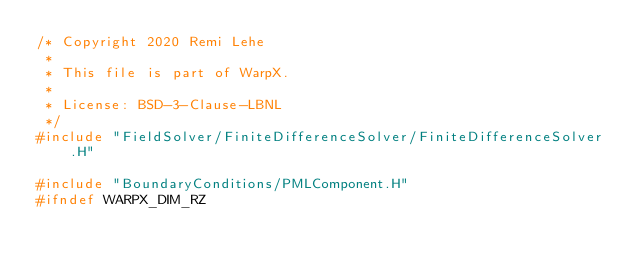Convert code to text. <code><loc_0><loc_0><loc_500><loc_500><_C++_>/* Copyright 2020 Remi Lehe
 *
 * This file is part of WarpX.
 *
 * License: BSD-3-Clause-LBNL
 */
#include "FieldSolver/FiniteDifferenceSolver/FiniteDifferenceSolver.H"

#include "BoundaryConditions/PMLComponent.H"
#ifndef WARPX_DIM_RZ</code> 